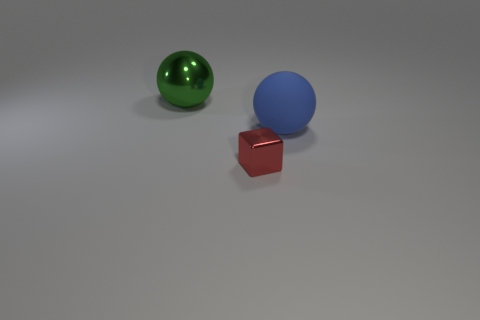Add 2 matte things. How many objects exist? 5 Subtract all spheres. How many objects are left? 1 Add 3 cubes. How many cubes are left? 4 Add 3 tiny red cylinders. How many tiny red cylinders exist? 3 Subtract 0 red balls. How many objects are left? 3 Subtract all big yellow cylinders. Subtract all big green balls. How many objects are left? 2 